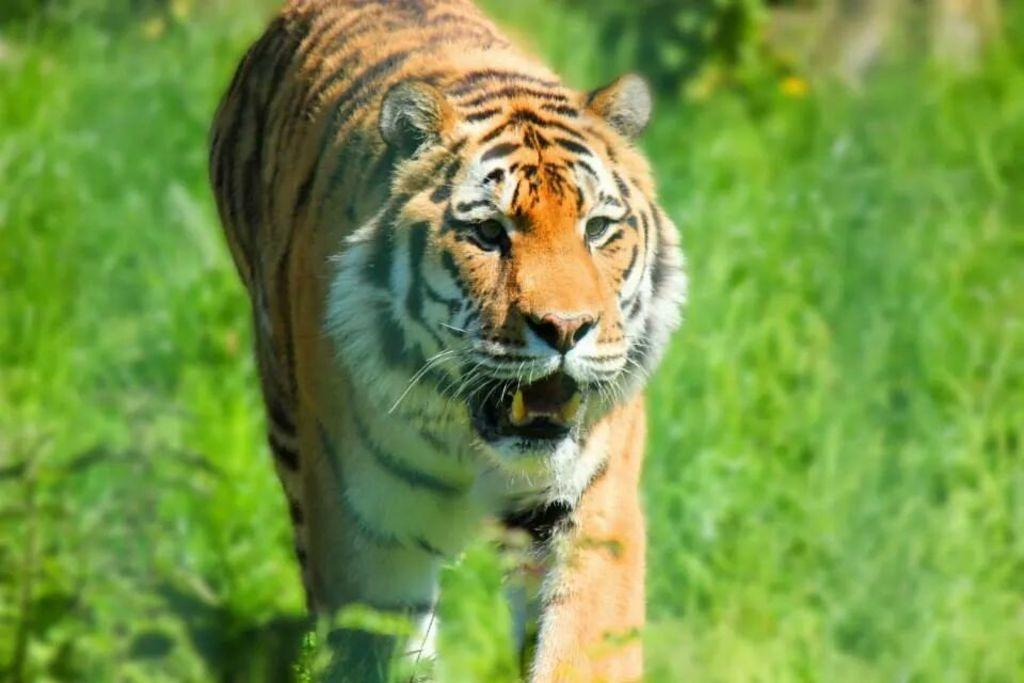What animal is the main subject of the image? There is a tiger in the image. What type of vegetation can be seen in the image? There are trees in the image. What color is predominant in the background of the image? The background of the image is green. How much does the donkey weigh in the image? There is no donkey present in the image, so its weight cannot be determined. 